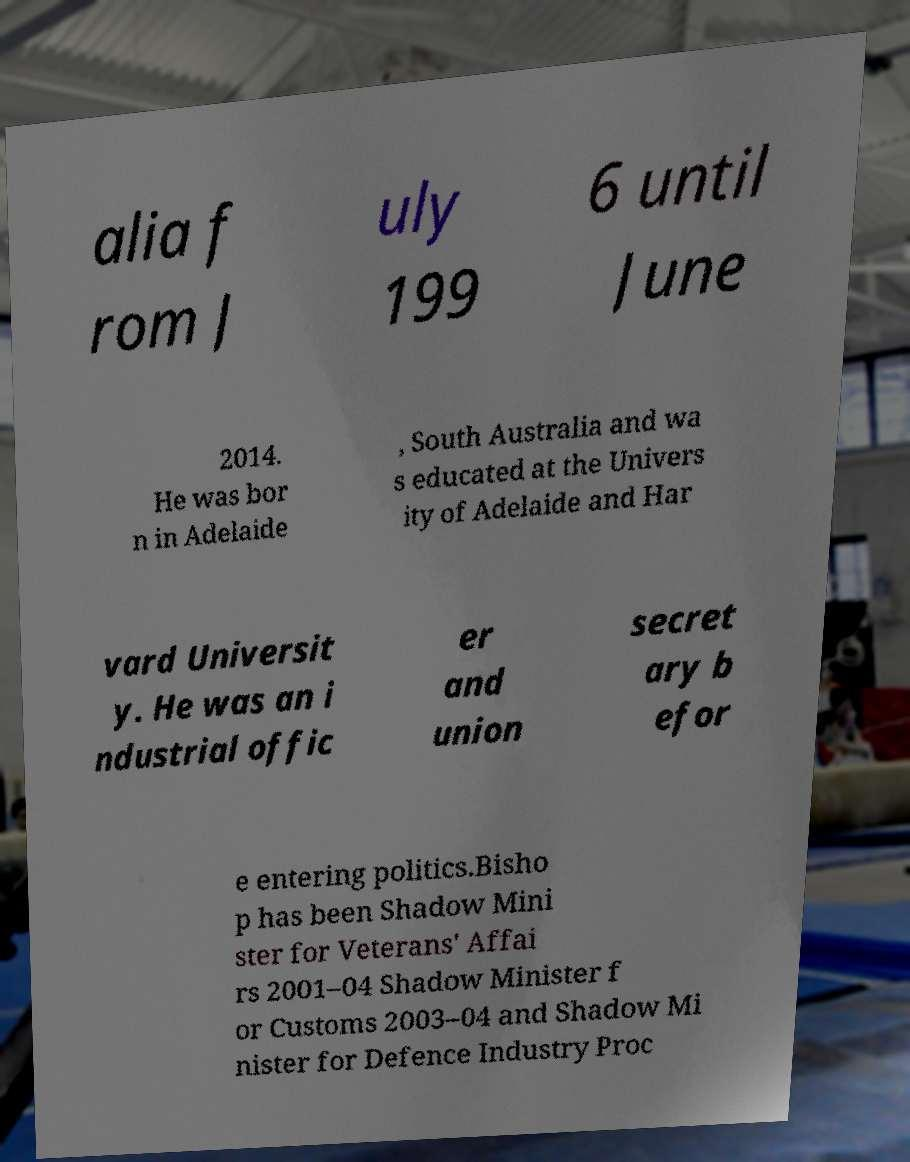What messages or text are displayed in this image? I need them in a readable, typed format. alia f rom J uly 199 6 until June 2014. He was bor n in Adelaide , South Australia and wa s educated at the Univers ity of Adelaide and Har vard Universit y. He was an i ndustrial offic er and union secret ary b efor e entering politics.Bisho p has been Shadow Mini ster for Veterans' Affai rs 2001–04 Shadow Minister f or Customs 2003–04 and Shadow Mi nister for Defence Industry Proc 